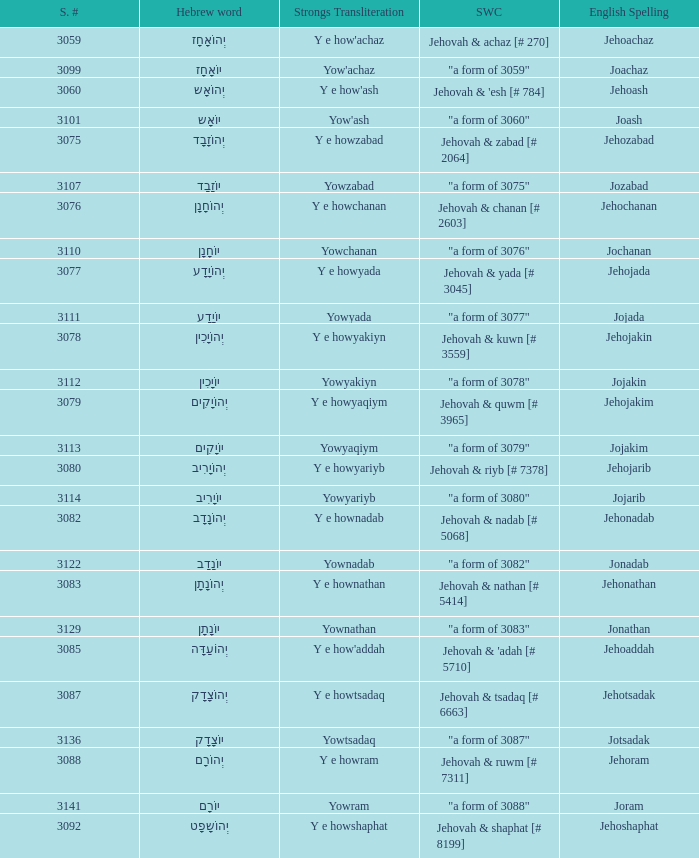What is the strongs words compounded when the english spelling is jonadab? "a form of 3082". 